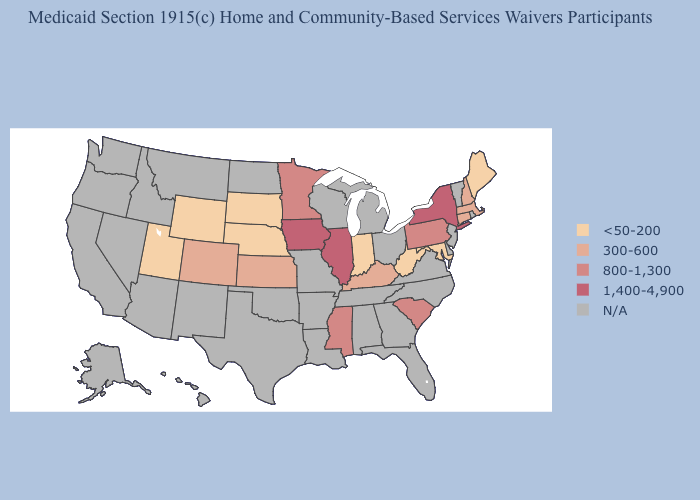Is the legend a continuous bar?
Write a very short answer. No. What is the value of Maine?
Answer briefly. <50-200. What is the value of Arizona?
Quick response, please. N/A. Does New York have the lowest value in the USA?
Answer briefly. No. Among the states that border Maryland , which have the highest value?
Be succinct. Pennsylvania. Name the states that have a value in the range <50-200?
Answer briefly. Indiana, Maine, Maryland, Nebraska, South Dakota, Utah, West Virginia, Wyoming. Name the states that have a value in the range 300-600?
Write a very short answer. Colorado, Connecticut, Kansas, Kentucky, Massachusetts, New Hampshire. Does the map have missing data?
Be succinct. Yes. What is the highest value in the USA?
Answer briefly. 1,400-4,900. Name the states that have a value in the range 800-1,300?
Write a very short answer. Minnesota, Mississippi, Pennsylvania, South Carolina. Which states have the lowest value in the West?
Keep it brief. Utah, Wyoming. What is the value of New Hampshire?
Concise answer only. 300-600. Name the states that have a value in the range N/A?
Be succinct. Alabama, Alaska, Arizona, Arkansas, California, Delaware, Florida, Georgia, Hawaii, Idaho, Louisiana, Michigan, Missouri, Montana, Nevada, New Jersey, New Mexico, North Carolina, North Dakota, Ohio, Oklahoma, Oregon, Rhode Island, Tennessee, Texas, Vermont, Virginia, Washington, Wisconsin. What is the lowest value in states that border Maine?
Short answer required. 300-600. Which states have the lowest value in the West?
Give a very brief answer. Utah, Wyoming. 